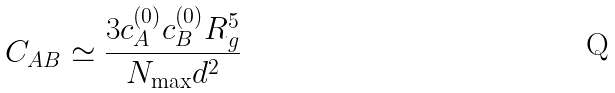<formula> <loc_0><loc_0><loc_500><loc_500>C _ { A B } \simeq \frac { 3 c ^ { ( 0 ) } _ { A } c ^ { ( 0 ) } _ { B } R _ { g } ^ { 5 } } { N _ { \max } d ^ { 2 } }</formula> 